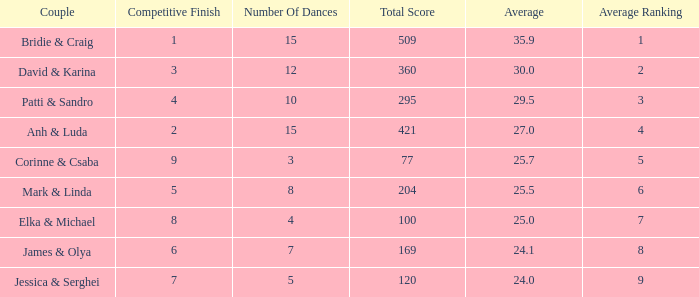What is the total score when 7 is the average ranking? 100.0. 